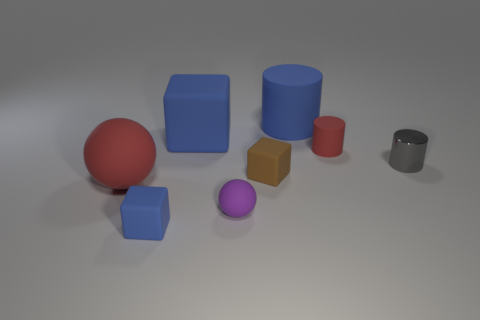Add 1 small red cylinders. How many objects exist? 9 Subtract all cubes. How many objects are left? 5 Add 5 big matte objects. How many big matte objects exist? 8 Subtract 0 gray balls. How many objects are left? 8 Subtract all small gray things. Subtract all gray metallic cylinders. How many objects are left? 6 Add 6 brown blocks. How many brown blocks are left? 7 